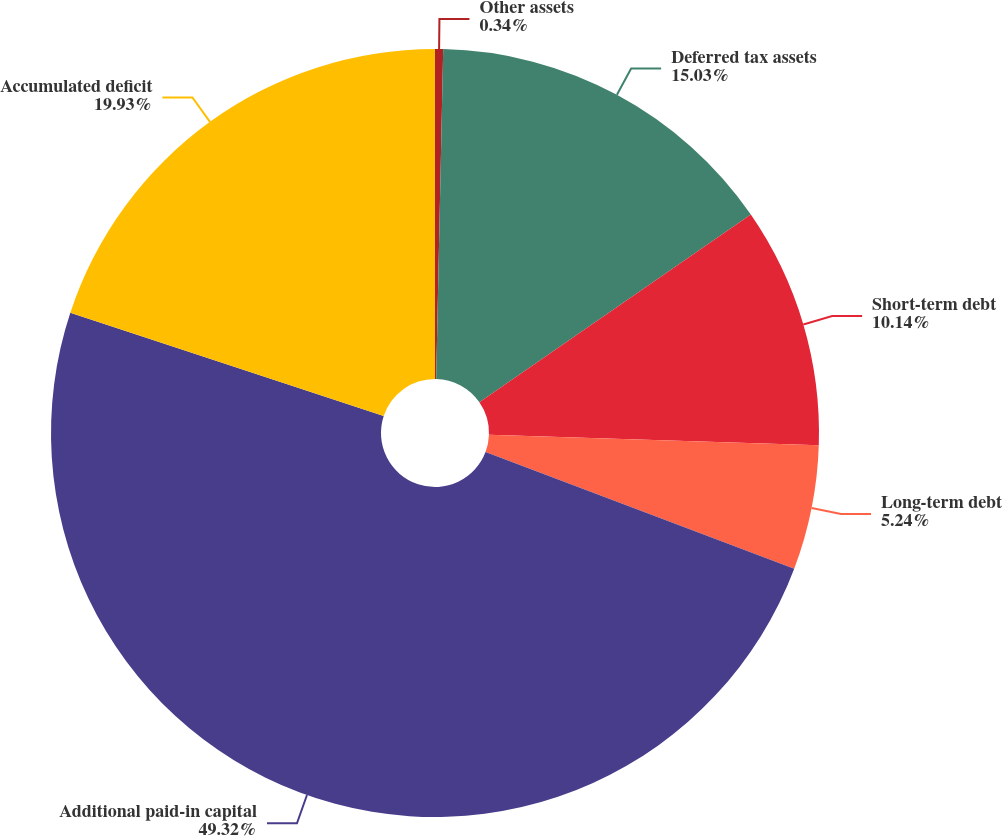Convert chart to OTSL. <chart><loc_0><loc_0><loc_500><loc_500><pie_chart><fcel>Other assets<fcel>Deferred tax assets<fcel>Short-term debt<fcel>Long-term debt<fcel>Additional paid-in capital<fcel>Accumulated deficit<nl><fcel>0.34%<fcel>15.03%<fcel>10.14%<fcel>5.24%<fcel>49.32%<fcel>19.93%<nl></chart> 